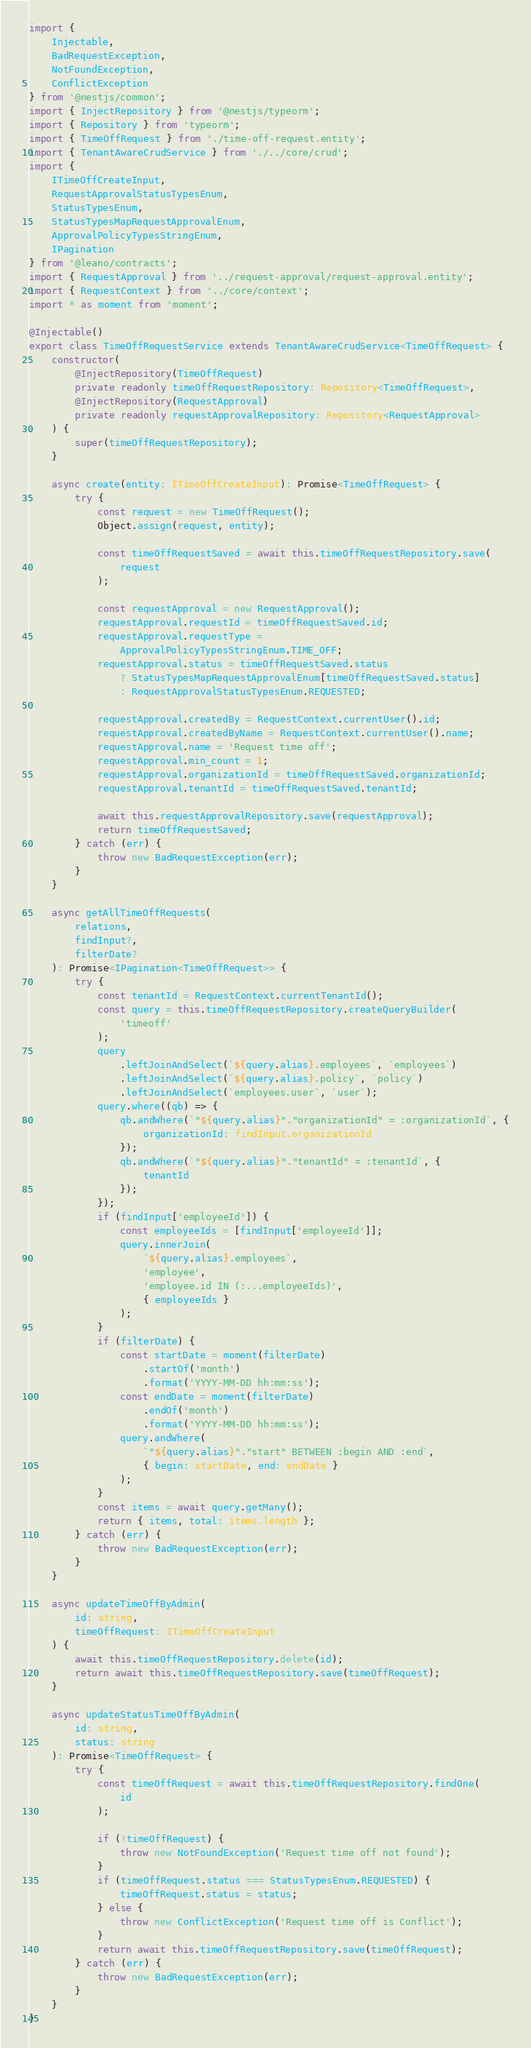Convert code to text. <code><loc_0><loc_0><loc_500><loc_500><_TypeScript_>import {
	Injectable,
	BadRequestException,
	NotFoundException,
	ConflictException
} from '@nestjs/common';
import { InjectRepository } from '@nestjs/typeorm';
import { Repository } from 'typeorm';
import { TimeOffRequest } from './time-off-request.entity';
import { TenantAwareCrudService } from './../core/crud';
import {
	ITimeOffCreateInput,
	RequestApprovalStatusTypesEnum,
	StatusTypesEnum,
	StatusTypesMapRequestApprovalEnum,
	ApprovalPolicyTypesStringEnum,
	IPagination
} from '@leano/contracts';
import { RequestApproval } from '../request-approval/request-approval.entity';
import { RequestContext } from '../core/context';
import * as moment from 'moment';

@Injectable()
export class TimeOffRequestService extends TenantAwareCrudService<TimeOffRequest> {
	constructor(
		@InjectRepository(TimeOffRequest)
		private readonly timeOffRequestRepository: Repository<TimeOffRequest>,
		@InjectRepository(RequestApproval)
		private readonly requestApprovalRepository: Repository<RequestApproval>
	) {
		super(timeOffRequestRepository);
	}

	async create(entity: ITimeOffCreateInput): Promise<TimeOffRequest> {
		try {
			const request = new TimeOffRequest();
			Object.assign(request, entity);

			const timeOffRequestSaved = await this.timeOffRequestRepository.save(
				request
			);

			const requestApproval = new RequestApproval();
			requestApproval.requestId = timeOffRequestSaved.id;
			requestApproval.requestType =
				ApprovalPolicyTypesStringEnum.TIME_OFF;
			requestApproval.status = timeOffRequestSaved.status
				? StatusTypesMapRequestApprovalEnum[timeOffRequestSaved.status]
				: RequestApprovalStatusTypesEnum.REQUESTED;

			requestApproval.createdBy = RequestContext.currentUser().id;
			requestApproval.createdByName = RequestContext.currentUser().name;
			requestApproval.name = 'Request time off';
			requestApproval.min_count = 1;
			requestApproval.organizationId = timeOffRequestSaved.organizationId;
			requestApproval.tenantId = timeOffRequestSaved.tenantId;

			await this.requestApprovalRepository.save(requestApproval);
			return timeOffRequestSaved;
		} catch (err) {
			throw new BadRequestException(err);
		}
	}

	async getAllTimeOffRequests(
		relations, 
		findInput?, 
		filterDate?
	): Promise<IPagination<TimeOffRequest>> {
		try {
			const tenantId = RequestContext.currentTenantId();
			const query = this.timeOffRequestRepository.createQueryBuilder(
				'timeoff'
			);
			query
				.leftJoinAndSelect(`${query.alias}.employees`, `employees`)
				.leftJoinAndSelect(`${query.alias}.policy`, `policy`)
				.leftJoinAndSelect(`employees.user`, `user`);
			query.where((qb) => {
				qb.andWhere(`"${query.alias}"."organizationId" = :organizationId`, {
					organizationId: findInput.organizationId
				});
				qb.andWhere(`"${query.alias}"."tenantId" = :tenantId`, {
					tenantId
				});
			});
			if (findInput['employeeId']) {
				const employeeIds = [findInput['employeeId']];
				query.innerJoin(
					`${query.alias}.employees`,
					'employee',
					'employee.id IN (:...employeeIds)',
					{ employeeIds }
				);
			}
			if (filterDate) {
				const startDate = moment(filterDate)
					.startOf('month')
					.format('YYYY-MM-DD hh:mm:ss');
				const endDate = moment(filterDate)
					.endOf('month')
					.format('YYYY-MM-DD hh:mm:ss');
				query.andWhere(
					`"${query.alias}"."start" BETWEEN :begin AND :end`,
					{ begin: startDate, end: endDate }
				);
			}
			const items = await query.getMany();
			return { items, total: items.length };
		} catch (err) {
			throw new BadRequestException(err);
		}
	}

	async updateTimeOffByAdmin(
		id: string,
		timeOffRequest: ITimeOffCreateInput
	) {
		await this.timeOffRequestRepository.delete(id);
		return await this.timeOffRequestRepository.save(timeOffRequest);
	}

	async updateStatusTimeOffByAdmin(
		id: string,
		status: string
	): Promise<TimeOffRequest> {
		try {
			const timeOffRequest = await this.timeOffRequestRepository.findOne(
				id
			);

			if (!timeOffRequest) {
				throw new NotFoundException('Request time off not found');
			}
			if (timeOffRequest.status === StatusTypesEnum.REQUESTED) {
				timeOffRequest.status = status;
			} else {
				throw new ConflictException('Request time off is Conflict');
			}
			return await this.timeOffRequestRepository.save(timeOffRequest);
		} catch (err) {
			throw new BadRequestException(err);
		}
	}
}
</code> 